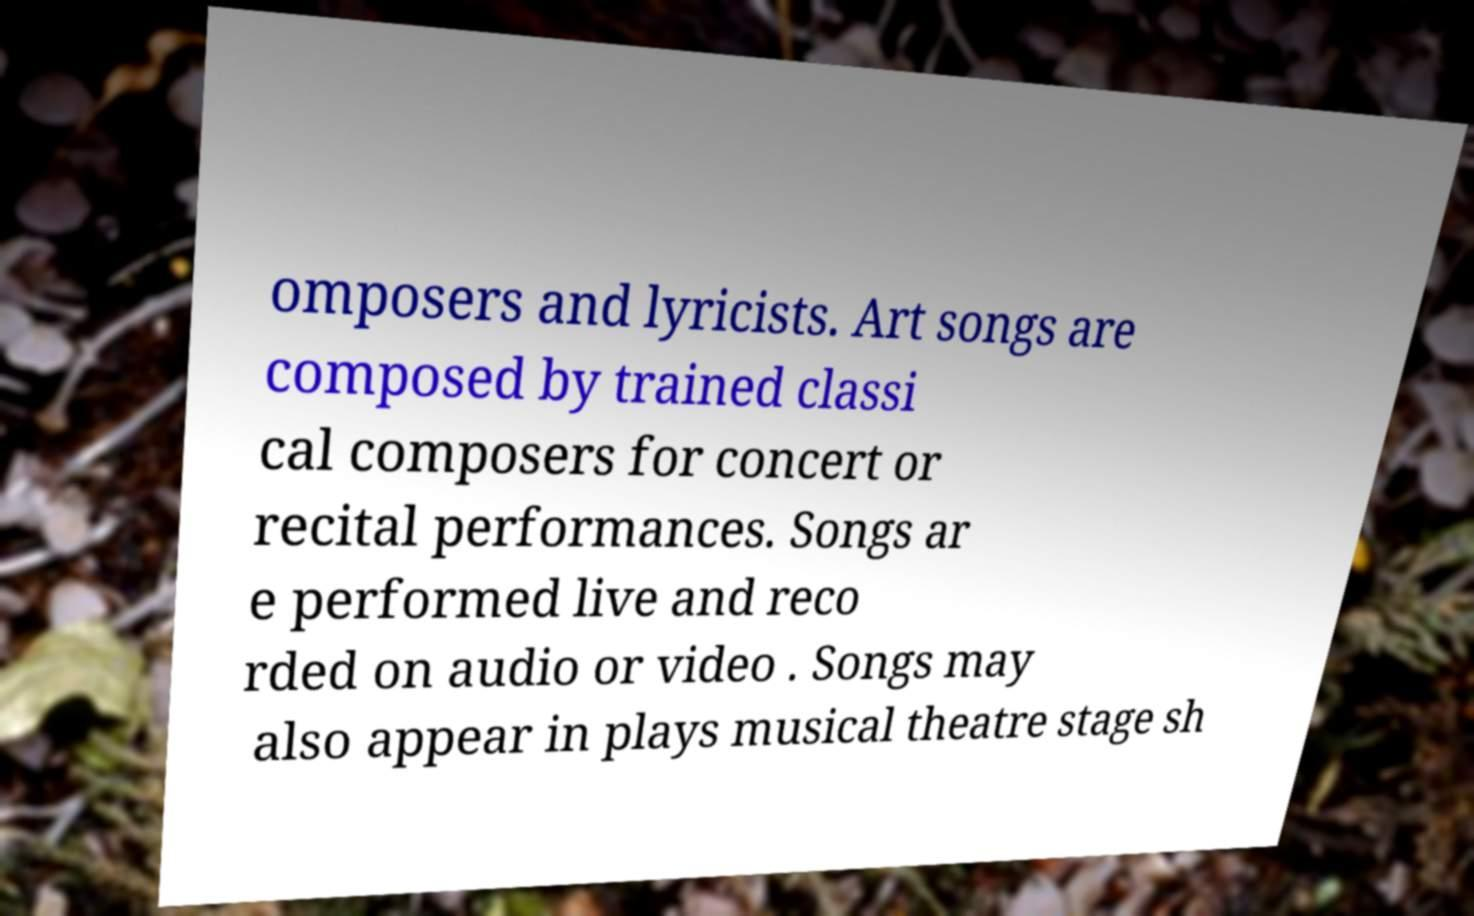Can you accurately transcribe the text from the provided image for me? omposers and lyricists. Art songs are composed by trained classi cal composers for concert or recital performances. Songs ar e performed live and reco rded on audio or video . Songs may also appear in plays musical theatre stage sh 